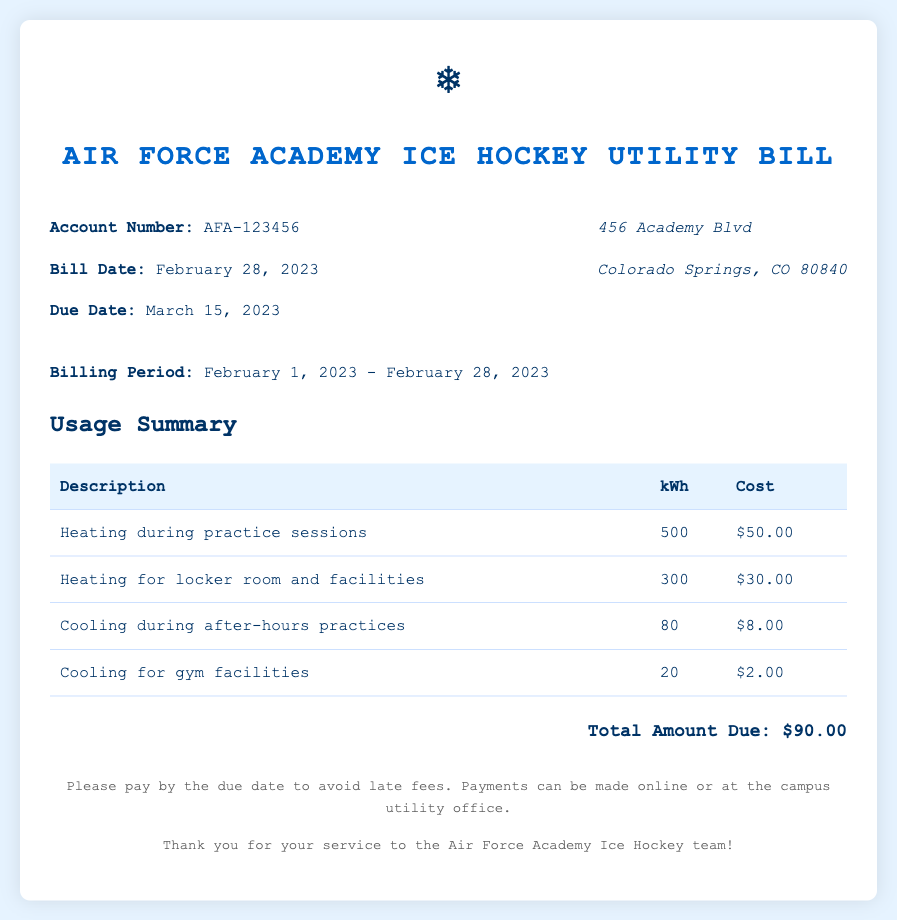What is the account number? The account number is listed in the header of the document.
Answer: AFA-123456 What is the total amount due? The total amount due is summarized at the bottom of the usage summary section.
Answer: $90.00 What was the billing period? The billing period is specified in the document just below the header.
Answer: February 1, 2023 - February 28, 2023 How much was spent on heating during practice sessions? The cost for heating during practice sessions is provided in the usage summary table.
Answer: $50.00 How many kilowatt-hours were used for cooling in gym facilities? The usage of cooling for gym facilities is detailed in the usage summary table.
Answer: 20 What is the due date for the bill? The due date is indicated in the header section of the document.
Answer: March 15, 2023 How much did the heating for locker room and facilities cost? The cost for heating related to locker room and facilities is shown in the usage summary table.
Answer: $30.00 How many kilowatt-hours were consumed for cooling during after-hours practices? The kilowatt-hours for cooling during after-hours practices are listed in the usage summary.
Answer: 80 What payment methods are available? The available payment methods are mentioned in the footer of the document.
Answer: Online or at the campus utility office 